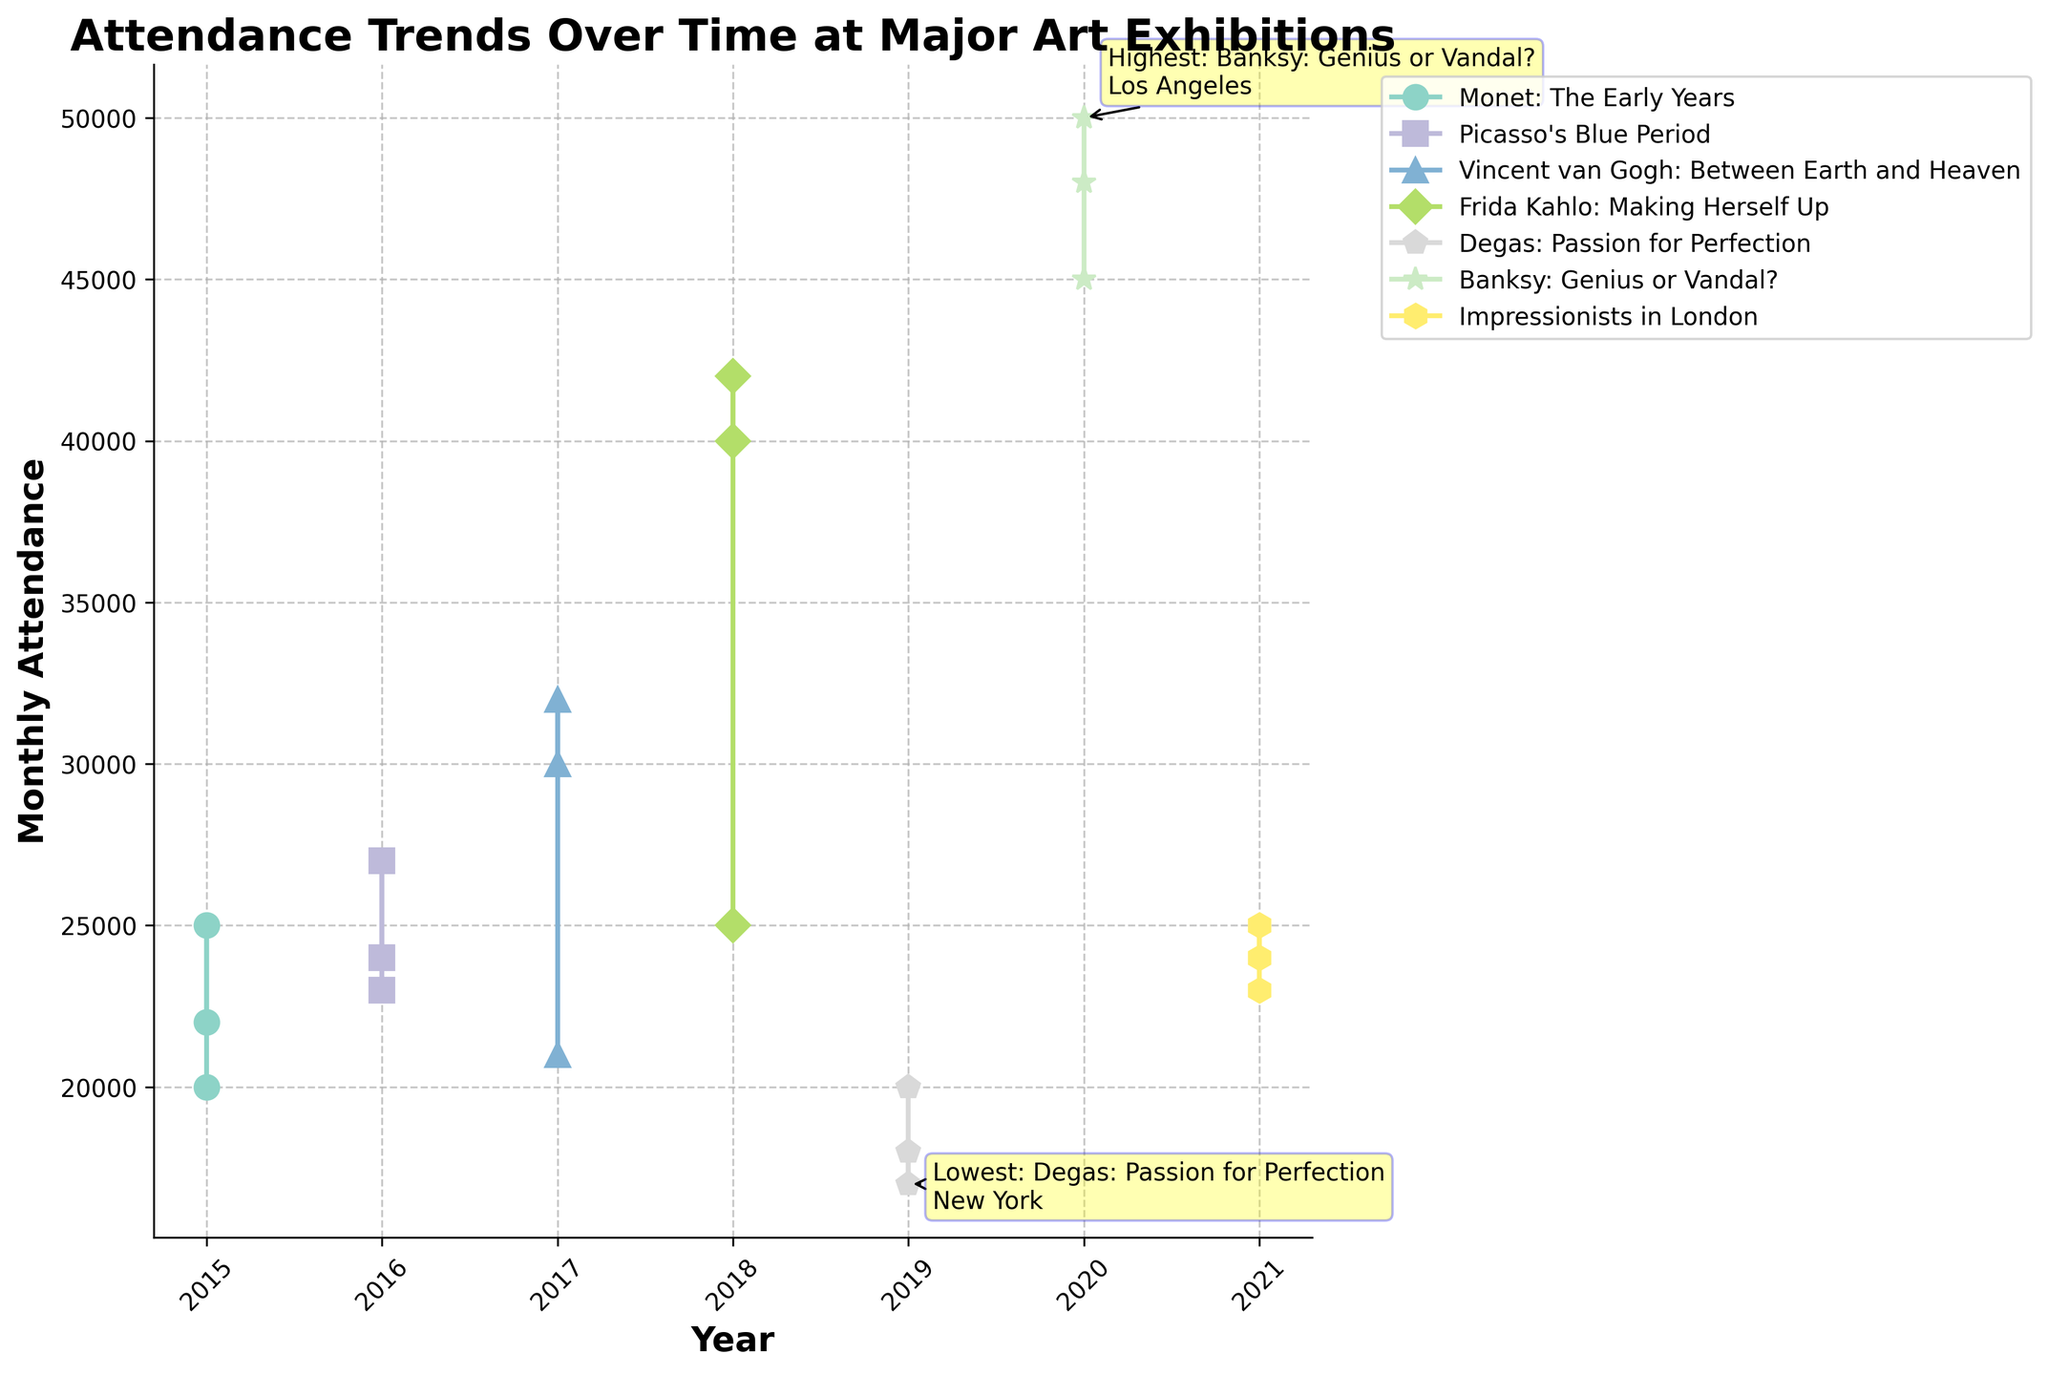Is there any particular exhibition with the highest monthly attendance? The highest monthly attendance is annotated with a yellow box and an arrow pointing to it on the plot. It's labeled as "Highest: Banksy: Genius or Vandal?\nLos Angeles". Therefore, the exhibition with the highest attendance is "Banksy: Genius or Vandal?" in Los Angeles.
Answer: Banksy: Genius or Vandal? What is the title of the figure? The title of the figure is usually displayed at the top of the plot. In this case, it's "Attendance Trends Over Time at Major Art Exhibitions".
Answer: Attendance Trends Over Time at Major Art Exhibitions Which exhibition had the lowest monthly attendance and where? The lowest monthly attendance is annotated on the plot with a yellow box and an arrow pointing to it. It is labeled as "Lowest: Degas: Passion for Perfection\nNew York". Therefore, the exhibition with the lowest attendance is "Degas: Passion for Perfection" in New York.
Answer: Degas: Passion for Perfection How does the monthly attendance for Picasso's Blue Period in 2016 in Madrid compare to that in Berlin? Compare the y-axis values at the year 2016 for "Picasso’s Blue Period" in Madrid and Berlin. The attendance in Madrid is higher at 27,000 compared to Berlin's 23,000.
Answer: Madrid had higher attendance What is the trend in attendance for Vincent van Gogh: Between Earth and Heaven across different cities in 2017? Observing the line for Vincent van Gogh: Between Earth and Heaven in 2017, Tokyo has 30,000, Amsterdam has 32,000, and Sydney has 21,000. The attendance starts medium in Tokyo, peaks in Amsterdam, and drops in Sydney.
Answer: Peaks in Amsterdam Which years had the highest variety of exhibitions? Count the unique exhibitions for each year. In 2018 and 2021, both had three different exhibitions, more than any other year.
Answer: 2018 and 2021 Between 2015 and 2020, which year shows the greatest fluctuation in monthly attendance? Observing the plotted lines between the years 2015 to 2020, 2020 shows significant fluctuations with very high attendance for Banksy and lower attendance for others.
Answer: 2020 Is there a general upward or downward trend in attendance from 2015 to 2021? By visually inspecting the lines from 2015 to 2021, there is no consistent upward or downward trend as it varies significantly year-to-year.
Answer: No consistent trend How did attendance change from 2019 to 2020 in the exhibitions? In 2019, attendance ranges from 17,000 to 20,000, while in 2020, it ranges from 45,000 to 50,000. The attendance significantly increased from 2019 to 2020.
Answer: Increased 